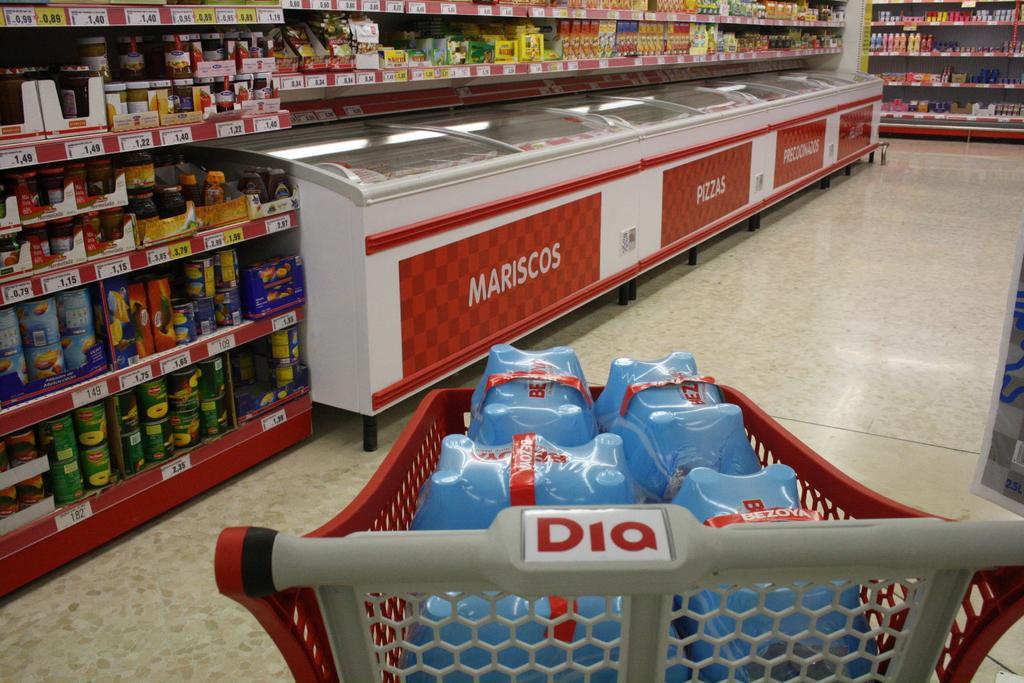<image>
Share a concise interpretation of the image provided. A cart from a Dia grocery store is in front a case that contains frozen pizza. 